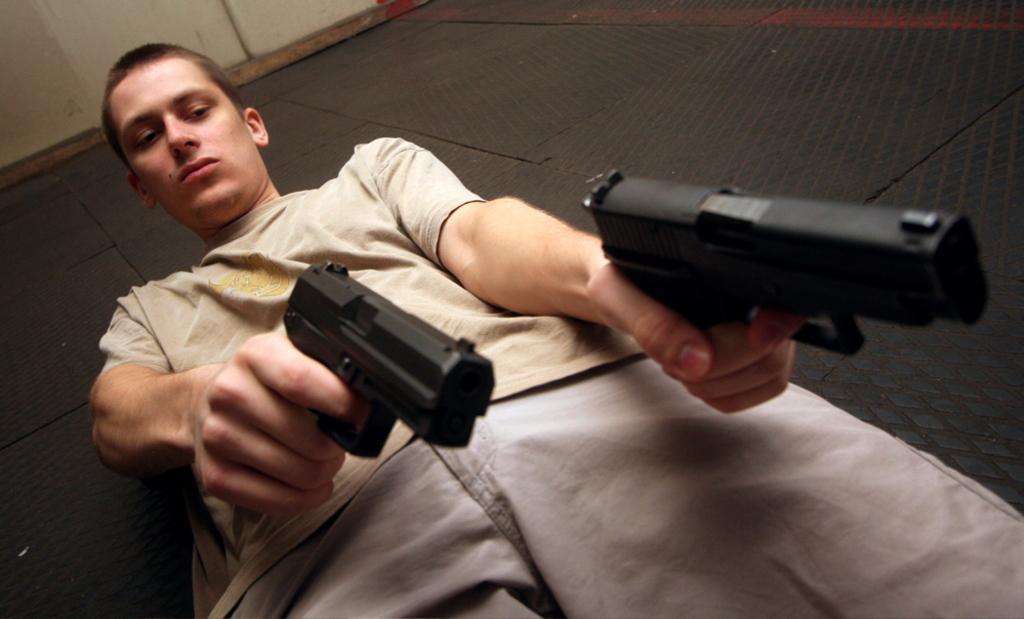What is present in the image that serves as a background or boundary? There is a wall in the image. What is the person in the image holding? The person is holding pistols in the image. What type of map can be seen on the wall in the image? There is no map present on the wall in the image. What kind of yam is the person holding in the image? The person is holding pistols, not a yam, in the image. 